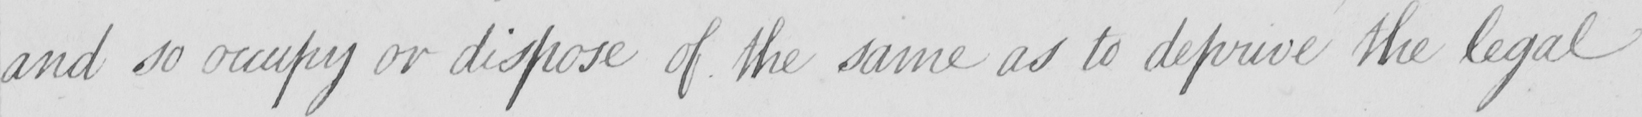Transcribe the text shown in this historical manuscript line. and so occupy or dispose of the same as to deprive the legal 